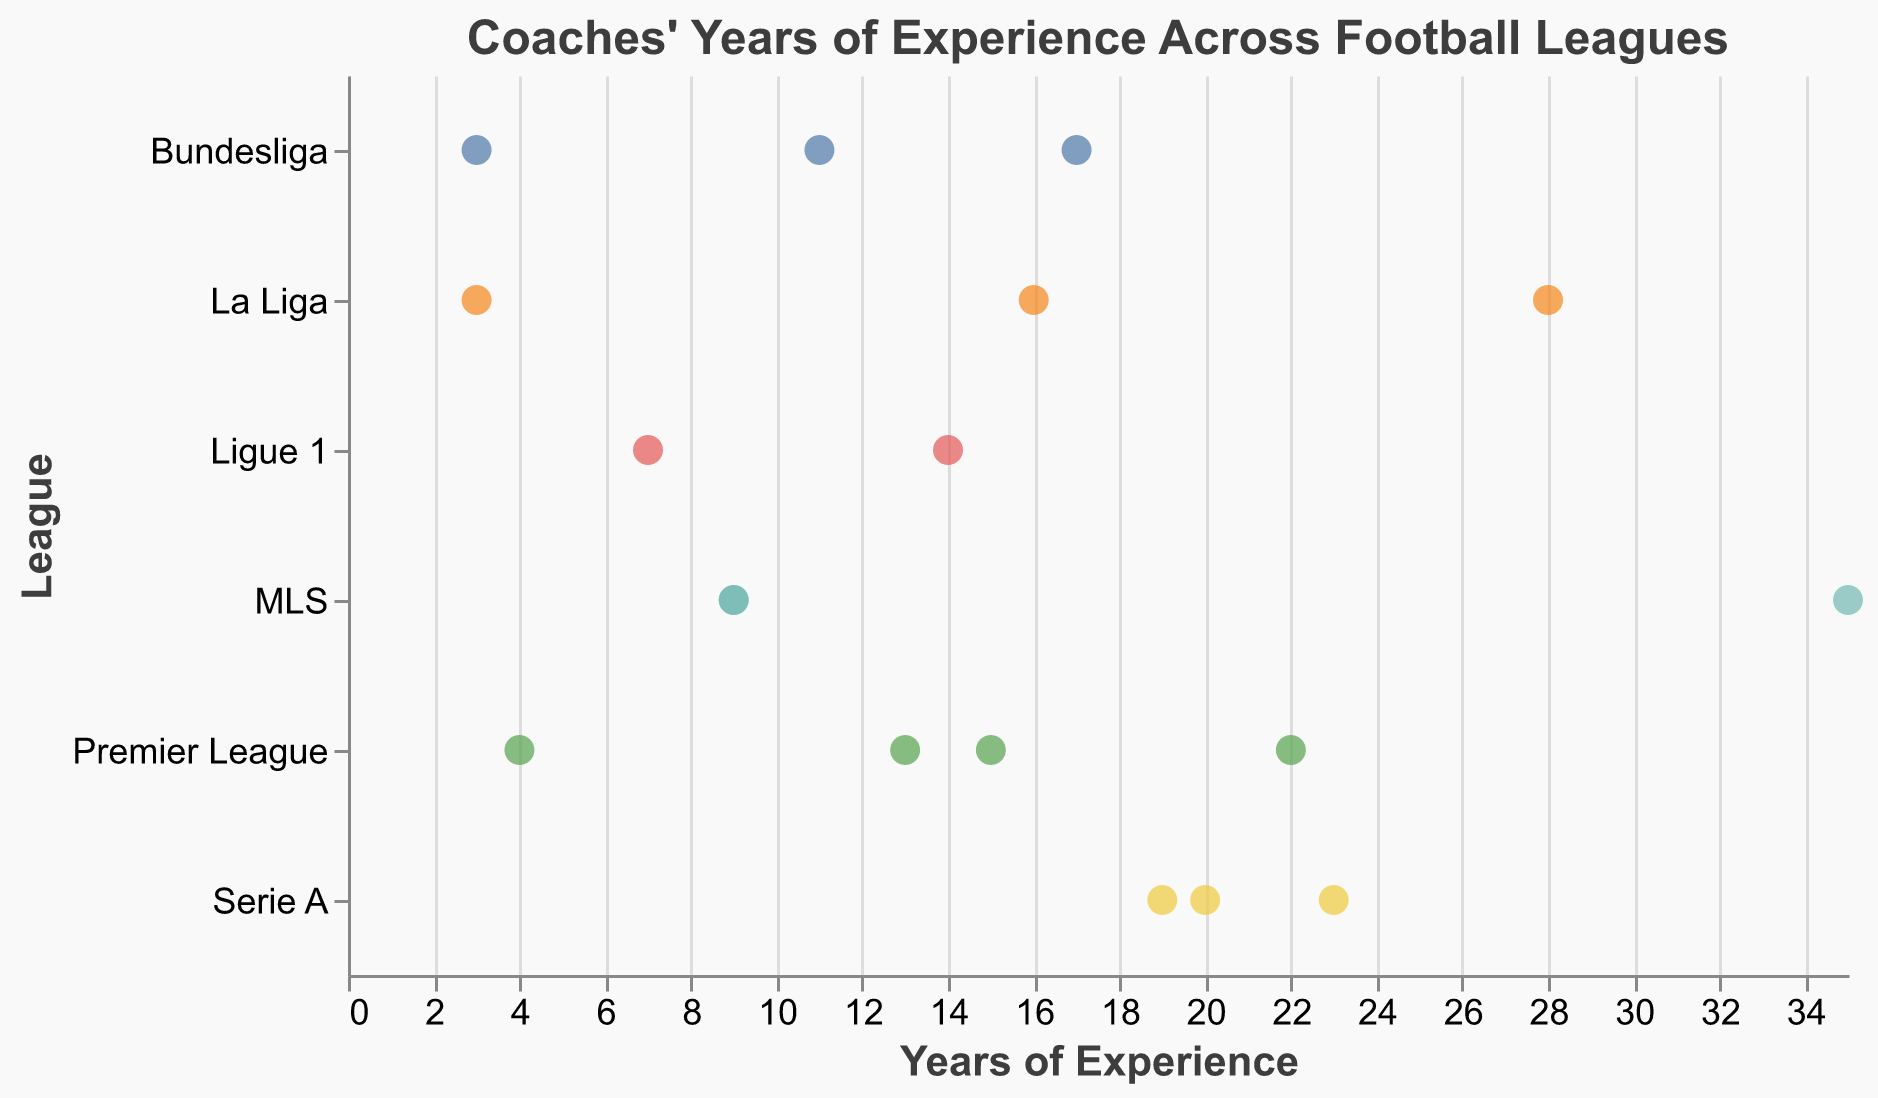How many leagues are displayed in the plot? Count the number of unique leagues shown on the y-axis.
Answer: 6 Which coach has the highest years of experience? Identify the data point that is farthest to the right on the x-axis, and check the tooltip or axis to find the coach's name.
Answer: Bruce Arena Which league has the most experienced coach? Identify the rightmost data point on the x-axis and check which league it belongs to.
Answer: MLS What is the range of years of experience for Premier League coaches? Identify the minimum and maximum years of experience for Premier League coaches on the x-axis. The minimum is 4 (Mikel Arteta), and the maximum is 22 (Jurgen Klopp). 22 - 4 = 18
Answer: 18 What is the average experience of La Liga coaches? Sum the years of experience for La Liga coaches and divide by the number of coaches. (28 + 3 + 16) / 3 = 47 / 3 ≈ 15.67
Answer: ≈ 15.67 Which coach in Serie A has the least experience? Identify the leftmost data point for Serie A coaches on the x-axis and check the tooltip or axis for the coach's name.
Answer: Massimiliano Allegri Are there any coaches with the same years of experience? If so, who are they? Look for data points that are aligned vertically along the same value on the x-axis. Identify the coaches and check the tooltips to confirm.
Answer: Greg Vanney and Jim Curtin How does the experience of Ligue 1 coaches compare to that of Bundesliga coaches? Compare the range and distribution of years of experience for both Ligue 1 and Bundesliga coaches along the x-axis. Ligue 1 has a range of 7 to 14 years, while Bundesliga has a range of 3 to 17 years. Ligue 1 generally has less experienced coaches compared to the Bundesliga.
Answer: Bundesliga generally has more experienced coaches What is the median years of experience for coaches in Serie A? Arrange the years of experience for Serie A coaches in order: 19, 20, 23. The middle value is 20.
Answer: 20 